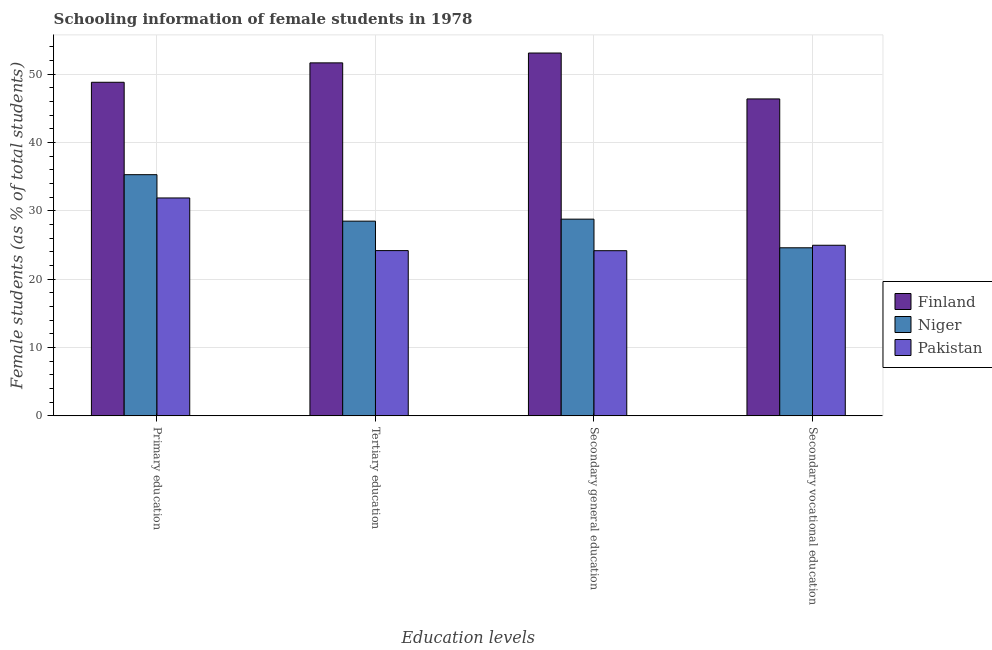How many different coloured bars are there?
Offer a terse response. 3. Are the number of bars on each tick of the X-axis equal?
Provide a succinct answer. Yes. How many bars are there on the 3rd tick from the right?
Ensure brevity in your answer.  3. What is the label of the 3rd group of bars from the left?
Provide a succinct answer. Secondary general education. What is the percentage of female students in secondary education in Pakistan?
Provide a short and direct response. 24.16. Across all countries, what is the maximum percentage of female students in tertiary education?
Keep it short and to the point. 51.63. Across all countries, what is the minimum percentage of female students in tertiary education?
Your response must be concise. 24.17. In which country was the percentage of female students in tertiary education maximum?
Ensure brevity in your answer.  Finland. In which country was the percentage of female students in secondary vocational education minimum?
Provide a succinct answer. Niger. What is the total percentage of female students in primary education in the graph?
Make the answer very short. 115.94. What is the difference between the percentage of female students in secondary vocational education in Pakistan and that in Finland?
Your response must be concise. -21.4. What is the difference between the percentage of female students in secondary vocational education in Pakistan and the percentage of female students in primary education in Niger?
Offer a terse response. -10.32. What is the average percentage of female students in primary education per country?
Offer a very short reply. 38.65. What is the difference between the percentage of female students in primary education and percentage of female students in secondary education in Finland?
Give a very brief answer. -4.28. What is the ratio of the percentage of female students in tertiary education in Pakistan to that in Finland?
Your response must be concise. 0.47. What is the difference between the highest and the second highest percentage of female students in secondary vocational education?
Give a very brief answer. 21.4. What is the difference between the highest and the lowest percentage of female students in primary education?
Provide a short and direct response. 16.92. What does the 1st bar from the left in Primary education represents?
Make the answer very short. Finland. How many bars are there?
Provide a succinct answer. 12. How many countries are there in the graph?
Offer a terse response. 3. What is the difference between two consecutive major ticks on the Y-axis?
Your answer should be very brief. 10. Does the graph contain any zero values?
Offer a terse response. No. Where does the legend appear in the graph?
Your answer should be very brief. Center right. What is the title of the graph?
Your response must be concise. Schooling information of female students in 1978. Does "Moldova" appear as one of the legend labels in the graph?
Give a very brief answer. No. What is the label or title of the X-axis?
Ensure brevity in your answer.  Education levels. What is the label or title of the Y-axis?
Provide a succinct answer. Female students (as % of total students). What is the Female students (as % of total students) in Finland in Primary education?
Provide a short and direct response. 48.79. What is the Female students (as % of total students) of Niger in Primary education?
Your answer should be compact. 35.28. What is the Female students (as % of total students) of Pakistan in Primary education?
Your answer should be compact. 31.87. What is the Female students (as % of total students) in Finland in Tertiary education?
Give a very brief answer. 51.63. What is the Female students (as % of total students) of Niger in Tertiary education?
Provide a short and direct response. 28.48. What is the Female students (as % of total students) in Pakistan in Tertiary education?
Your response must be concise. 24.17. What is the Female students (as % of total students) in Finland in Secondary general education?
Give a very brief answer. 53.07. What is the Female students (as % of total students) of Niger in Secondary general education?
Offer a very short reply. 28.77. What is the Female students (as % of total students) of Pakistan in Secondary general education?
Keep it short and to the point. 24.16. What is the Female students (as % of total students) in Finland in Secondary vocational education?
Ensure brevity in your answer.  46.35. What is the Female students (as % of total students) of Niger in Secondary vocational education?
Provide a short and direct response. 24.58. What is the Female students (as % of total students) of Pakistan in Secondary vocational education?
Your response must be concise. 24.95. Across all Education levels, what is the maximum Female students (as % of total students) in Finland?
Give a very brief answer. 53.07. Across all Education levels, what is the maximum Female students (as % of total students) of Niger?
Your answer should be compact. 35.28. Across all Education levels, what is the maximum Female students (as % of total students) of Pakistan?
Keep it short and to the point. 31.87. Across all Education levels, what is the minimum Female students (as % of total students) of Finland?
Your response must be concise. 46.35. Across all Education levels, what is the minimum Female students (as % of total students) of Niger?
Your answer should be compact. 24.58. Across all Education levels, what is the minimum Female students (as % of total students) of Pakistan?
Provide a succinct answer. 24.16. What is the total Female students (as % of total students) in Finland in the graph?
Give a very brief answer. 199.84. What is the total Female students (as % of total students) of Niger in the graph?
Your answer should be compact. 117.11. What is the total Female students (as % of total students) in Pakistan in the graph?
Ensure brevity in your answer.  105.15. What is the difference between the Female students (as % of total students) of Finland in Primary education and that in Tertiary education?
Offer a terse response. -2.84. What is the difference between the Female students (as % of total students) of Niger in Primary education and that in Tertiary education?
Offer a terse response. 6.8. What is the difference between the Female students (as % of total students) of Pakistan in Primary education and that in Tertiary education?
Keep it short and to the point. 7.7. What is the difference between the Female students (as % of total students) in Finland in Primary education and that in Secondary general education?
Your response must be concise. -4.28. What is the difference between the Female students (as % of total students) of Niger in Primary education and that in Secondary general education?
Provide a short and direct response. 6.5. What is the difference between the Female students (as % of total students) in Pakistan in Primary education and that in Secondary general education?
Keep it short and to the point. 7.71. What is the difference between the Female students (as % of total students) of Finland in Primary education and that in Secondary vocational education?
Provide a short and direct response. 2.44. What is the difference between the Female students (as % of total students) in Niger in Primary education and that in Secondary vocational education?
Provide a succinct answer. 10.69. What is the difference between the Female students (as % of total students) in Pakistan in Primary education and that in Secondary vocational education?
Provide a short and direct response. 6.92. What is the difference between the Female students (as % of total students) of Finland in Tertiary education and that in Secondary general education?
Offer a terse response. -1.44. What is the difference between the Female students (as % of total students) of Niger in Tertiary education and that in Secondary general education?
Offer a very short reply. -0.29. What is the difference between the Female students (as % of total students) of Pakistan in Tertiary education and that in Secondary general education?
Offer a terse response. 0.01. What is the difference between the Female students (as % of total students) of Finland in Tertiary education and that in Secondary vocational education?
Provide a short and direct response. 5.27. What is the difference between the Female students (as % of total students) of Niger in Tertiary education and that in Secondary vocational education?
Provide a succinct answer. 3.9. What is the difference between the Female students (as % of total students) in Pakistan in Tertiary education and that in Secondary vocational education?
Your answer should be very brief. -0.78. What is the difference between the Female students (as % of total students) of Finland in Secondary general education and that in Secondary vocational education?
Keep it short and to the point. 6.71. What is the difference between the Female students (as % of total students) of Niger in Secondary general education and that in Secondary vocational education?
Your answer should be compact. 4.19. What is the difference between the Female students (as % of total students) of Pakistan in Secondary general education and that in Secondary vocational education?
Give a very brief answer. -0.79. What is the difference between the Female students (as % of total students) in Finland in Primary education and the Female students (as % of total students) in Niger in Tertiary education?
Offer a terse response. 20.31. What is the difference between the Female students (as % of total students) of Finland in Primary education and the Female students (as % of total students) of Pakistan in Tertiary education?
Offer a very short reply. 24.62. What is the difference between the Female students (as % of total students) of Niger in Primary education and the Female students (as % of total students) of Pakistan in Tertiary education?
Your answer should be very brief. 11.1. What is the difference between the Female students (as % of total students) of Finland in Primary education and the Female students (as % of total students) of Niger in Secondary general education?
Your response must be concise. 20.02. What is the difference between the Female students (as % of total students) in Finland in Primary education and the Female students (as % of total students) in Pakistan in Secondary general education?
Your response must be concise. 24.63. What is the difference between the Female students (as % of total students) of Niger in Primary education and the Female students (as % of total students) of Pakistan in Secondary general education?
Your answer should be compact. 11.12. What is the difference between the Female students (as % of total students) of Finland in Primary education and the Female students (as % of total students) of Niger in Secondary vocational education?
Offer a terse response. 24.21. What is the difference between the Female students (as % of total students) of Finland in Primary education and the Female students (as % of total students) of Pakistan in Secondary vocational education?
Give a very brief answer. 23.84. What is the difference between the Female students (as % of total students) of Niger in Primary education and the Female students (as % of total students) of Pakistan in Secondary vocational education?
Your response must be concise. 10.32. What is the difference between the Female students (as % of total students) in Finland in Tertiary education and the Female students (as % of total students) in Niger in Secondary general education?
Make the answer very short. 22.86. What is the difference between the Female students (as % of total students) of Finland in Tertiary education and the Female students (as % of total students) of Pakistan in Secondary general education?
Your answer should be compact. 27.47. What is the difference between the Female students (as % of total students) of Niger in Tertiary education and the Female students (as % of total students) of Pakistan in Secondary general education?
Your answer should be very brief. 4.32. What is the difference between the Female students (as % of total students) in Finland in Tertiary education and the Female students (as % of total students) in Niger in Secondary vocational education?
Ensure brevity in your answer.  27.05. What is the difference between the Female students (as % of total students) in Finland in Tertiary education and the Female students (as % of total students) in Pakistan in Secondary vocational education?
Give a very brief answer. 26.68. What is the difference between the Female students (as % of total students) in Niger in Tertiary education and the Female students (as % of total students) in Pakistan in Secondary vocational education?
Ensure brevity in your answer.  3.53. What is the difference between the Female students (as % of total students) of Finland in Secondary general education and the Female students (as % of total students) of Niger in Secondary vocational education?
Keep it short and to the point. 28.49. What is the difference between the Female students (as % of total students) in Finland in Secondary general education and the Female students (as % of total students) in Pakistan in Secondary vocational education?
Ensure brevity in your answer.  28.12. What is the difference between the Female students (as % of total students) in Niger in Secondary general education and the Female students (as % of total students) in Pakistan in Secondary vocational education?
Offer a very short reply. 3.82. What is the average Female students (as % of total students) of Finland per Education levels?
Make the answer very short. 49.96. What is the average Female students (as % of total students) of Niger per Education levels?
Ensure brevity in your answer.  29.28. What is the average Female students (as % of total students) of Pakistan per Education levels?
Your response must be concise. 26.29. What is the difference between the Female students (as % of total students) in Finland and Female students (as % of total students) in Niger in Primary education?
Provide a succinct answer. 13.51. What is the difference between the Female students (as % of total students) in Finland and Female students (as % of total students) in Pakistan in Primary education?
Ensure brevity in your answer.  16.92. What is the difference between the Female students (as % of total students) of Niger and Female students (as % of total students) of Pakistan in Primary education?
Make the answer very short. 3.41. What is the difference between the Female students (as % of total students) in Finland and Female students (as % of total students) in Niger in Tertiary education?
Your answer should be compact. 23.15. What is the difference between the Female students (as % of total students) in Finland and Female students (as % of total students) in Pakistan in Tertiary education?
Provide a short and direct response. 27.46. What is the difference between the Female students (as % of total students) in Niger and Female students (as % of total students) in Pakistan in Tertiary education?
Your answer should be compact. 4.31. What is the difference between the Female students (as % of total students) in Finland and Female students (as % of total students) in Niger in Secondary general education?
Ensure brevity in your answer.  24.3. What is the difference between the Female students (as % of total students) of Finland and Female students (as % of total students) of Pakistan in Secondary general education?
Your answer should be very brief. 28.91. What is the difference between the Female students (as % of total students) of Niger and Female students (as % of total students) of Pakistan in Secondary general education?
Your response must be concise. 4.61. What is the difference between the Female students (as % of total students) in Finland and Female students (as % of total students) in Niger in Secondary vocational education?
Ensure brevity in your answer.  21.77. What is the difference between the Female students (as % of total students) of Finland and Female students (as % of total students) of Pakistan in Secondary vocational education?
Make the answer very short. 21.4. What is the difference between the Female students (as % of total students) of Niger and Female students (as % of total students) of Pakistan in Secondary vocational education?
Provide a succinct answer. -0.37. What is the ratio of the Female students (as % of total students) in Finland in Primary education to that in Tertiary education?
Your answer should be compact. 0.94. What is the ratio of the Female students (as % of total students) in Niger in Primary education to that in Tertiary education?
Provide a short and direct response. 1.24. What is the ratio of the Female students (as % of total students) of Pakistan in Primary education to that in Tertiary education?
Ensure brevity in your answer.  1.32. What is the ratio of the Female students (as % of total students) of Finland in Primary education to that in Secondary general education?
Make the answer very short. 0.92. What is the ratio of the Female students (as % of total students) of Niger in Primary education to that in Secondary general education?
Make the answer very short. 1.23. What is the ratio of the Female students (as % of total students) of Pakistan in Primary education to that in Secondary general education?
Provide a short and direct response. 1.32. What is the ratio of the Female students (as % of total students) in Finland in Primary education to that in Secondary vocational education?
Provide a succinct answer. 1.05. What is the ratio of the Female students (as % of total students) of Niger in Primary education to that in Secondary vocational education?
Offer a terse response. 1.44. What is the ratio of the Female students (as % of total students) of Pakistan in Primary education to that in Secondary vocational education?
Ensure brevity in your answer.  1.28. What is the ratio of the Female students (as % of total students) of Finland in Tertiary education to that in Secondary general education?
Make the answer very short. 0.97. What is the ratio of the Female students (as % of total students) in Niger in Tertiary education to that in Secondary general education?
Offer a very short reply. 0.99. What is the ratio of the Female students (as % of total students) of Finland in Tertiary education to that in Secondary vocational education?
Your answer should be very brief. 1.11. What is the ratio of the Female students (as % of total students) of Niger in Tertiary education to that in Secondary vocational education?
Provide a short and direct response. 1.16. What is the ratio of the Female students (as % of total students) in Pakistan in Tertiary education to that in Secondary vocational education?
Offer a very short reply. 0.97. What is the ratio of the Female students (as % of total students) in Finland in Secondary general education to that in Secondary vocational education?
Ensure brevity in your answer.  1.14. What is the ratio of the Female students (as % of total students) in Niger in Secondary general education to that in Secondary vocational education?
Ensure brevity in your answer.  1.17. What is the ratio of the Female students (as % of total students) in Pakistan in Secondary general education to that in Secondary vocational education?
Make the answer very short. 0.97. What is the difference between the highest and the second highest Female students (as % of total students) of Finland?
Your response must be concise. 1.44. What is the difference between the highest and the second highest Female students (as % of total students) of Niger?
Your response must be concise. 6.5. What is the difference between the highest and the second highest Female students (as % of total students) of Pakistan?
Give a very brief answer. 6.92. What is the difference between the highest and the lowest Female students (as % of total students) of Finland?
Your response must be concise. 6.71. What is the difference between the highest and the lowest Female students (as % of total students) of Niger?
Ensure brevity in your answer.  10.69. What is the difference between the highest and the lowest Female students (as % of total students) in Pakistan?
Your answer should be very brief. 7.71. 